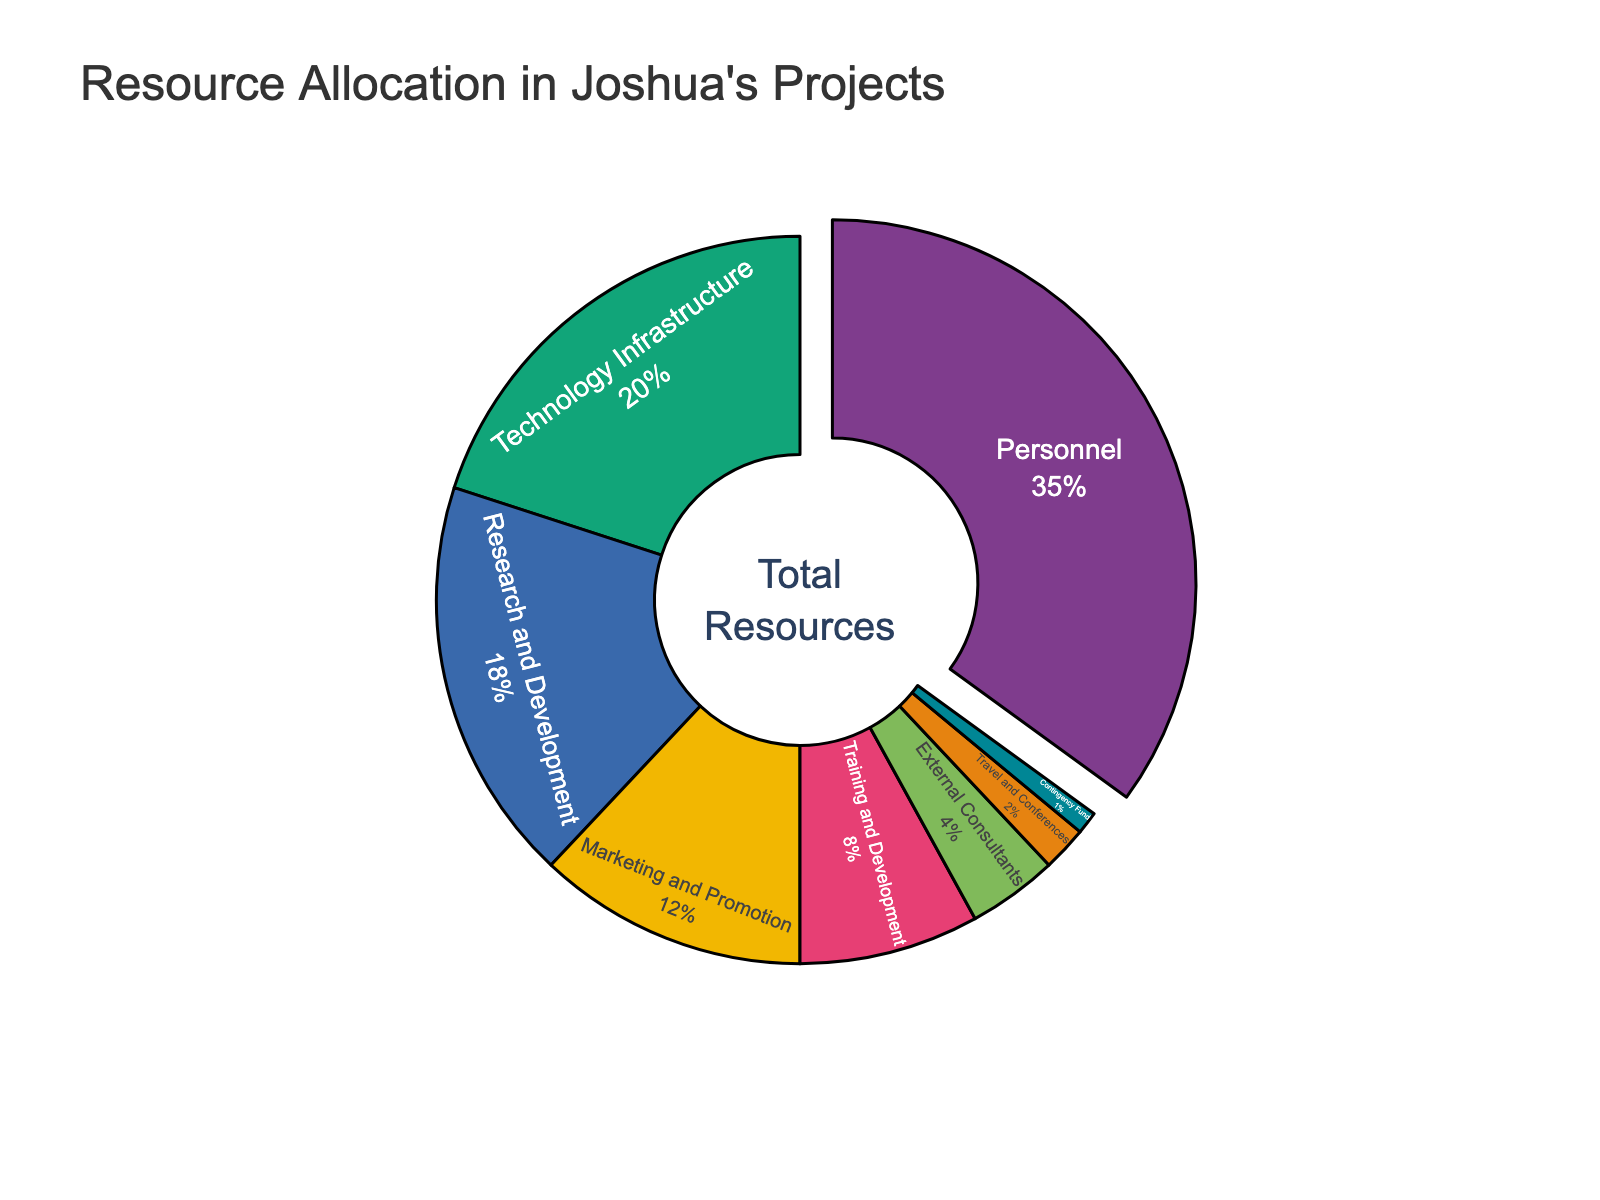What is the largest allocation of resources in Joshua's projects? The largest segment in the pie chart represents "Personnel" with a 35% allocation. This is indicated by the largest and slightly pulled-out segment.
Answer: Personnel Comparing Technology Infrastructure and Marketing and Promotion, which one has a higher percentage allocation? The pie chart shows that "Technology Infrastructure" has 20%, while "Marketing and Promotion" has 12%. Therefore, Technology Infrastructure has a higher allocation.
Answer: Technology Infrastructure What's the combined percentage allocated to Research and Development and External Consultants? Research and Development is 18% and External Consultants is 4%. Adding these together: 18% + 4% = 22%.
Answer: 22% Which resource type has the smallest allocation, and what is the percentage? The smallest segment in the pie chart represents the "Contingency Fund" with a 1% allocation.
Answer: Contingency Fund, 1% By how much does the percentage allocation for Personnel exceed that of Travel and Conferences? The percentage for Personnel is 35% and for Travel and Conferences is 2%. The difference is 35% - 2% = 33%.
Answer: 33% What is the total allocation percentage for resources excluding Personnel? Excluding Personnel (35%), sum the percentages of all other segments: 20 (Technology Infrastructure) + 18 (Research and Development) + 12 (Marketing and Promotion) + 8 (Training and Development) + 4 (External Consultants) + 2 (Travel and Conferences) + 1 (Contingency Fund) = 65%.
Answer: 65% Are the combined allocations for Training and Development and Travel and Conferences more or less than the allocation for Research and Development? Training and Development is 8%, and Travel and Conferences is 2%. Combined, this is 8% + 2% = 10%. Research and Development is 18%. Therefore, the combined allocation (10%) is less than Research and Development (18%).
Answer: Less What portion of the pie chart does Marketing and Promotion occupy relative to Technology Infrastructure? Marketing and Promotion is at 12%, while Technology Infrastructure is at 20%. Therefore, Marketing and Promotion is 12/20 = 0.6, which means it is 60% of Technology Infrastructure's allocation.
Answer: 60% What percentage of resources is allocated to elements associated with personnel, training, and external consultants combined? Personnel is 35%, Training and Development is 8%, and External Consultants is 4%. Adding these together: 35% + 8% + 4% = 47%.
Answer: 47% Which two resource types together make up roughly one-third of the total allocation? Research and Development is 18%, and Training and Development is 8%. Together, 18% + 8% = 26%, which is closest to one-third of 100% (about 33%). The more precise combination closest to one-third includes another small slice, but given the segments provided, the closest reasonable two-type combination is Research and Development and Training and Development.
Answer: Research and Development and Training and Development 